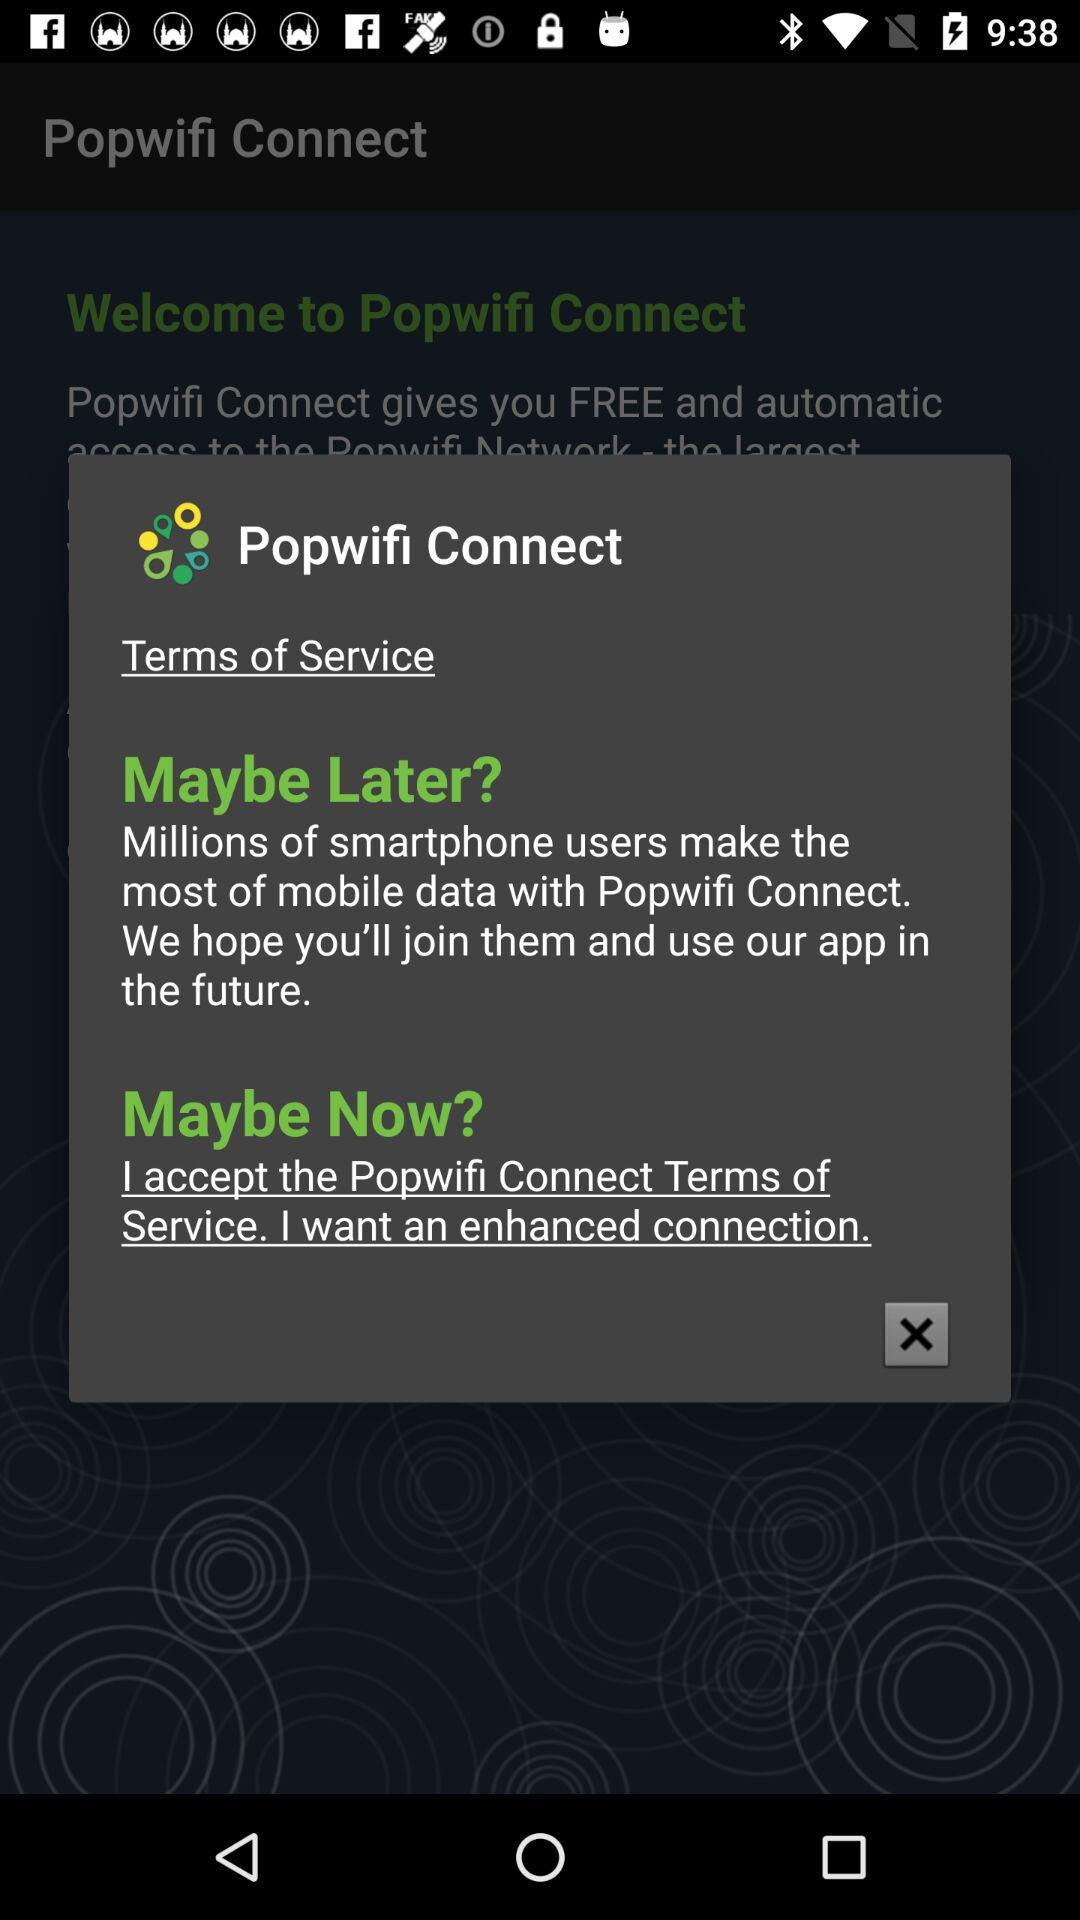What is the application name? The application name is "Popwifi Connect". 